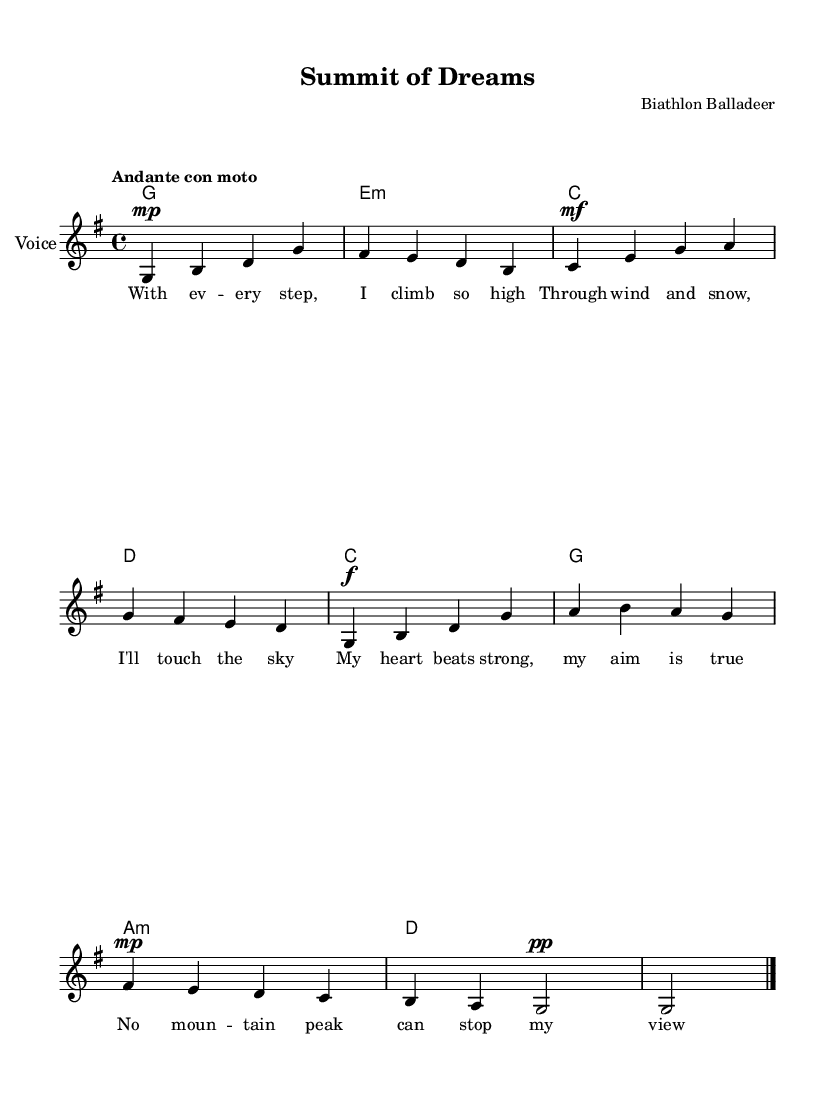What is the key signature of this music? The key signature is G major, which has one sharp (F-sharp).
Answer: G major What is the time signature? The time signature is 4/4, indicating four beats per measure.
Answer: 4/4 What is the tempo marking for this piece? The tempo marking indicates "Andante con moto," suggesting a moderate, flowing pace.
Answer: Andante con moto How many measures are there in the piece? By counting the measures shown in the sheet music, we find there are 8 measures in total.
Answer: 8 Which musical form does this song represent? The song features a simple verse structure with lyrics, typical for a ballad.
Answer: Verse structure What dynamics are indicated in the melody? Dynamics include mezzo-piano (mp), mezzo-forte (mf), and forte (f) at different parts of the melody, indicating varying volume levels.
Answer: mp, mf, f What is the title of this song? The title "Summit of Dreams" is clearly displayed at the top of the score.
Answer: Summit of Dreams 